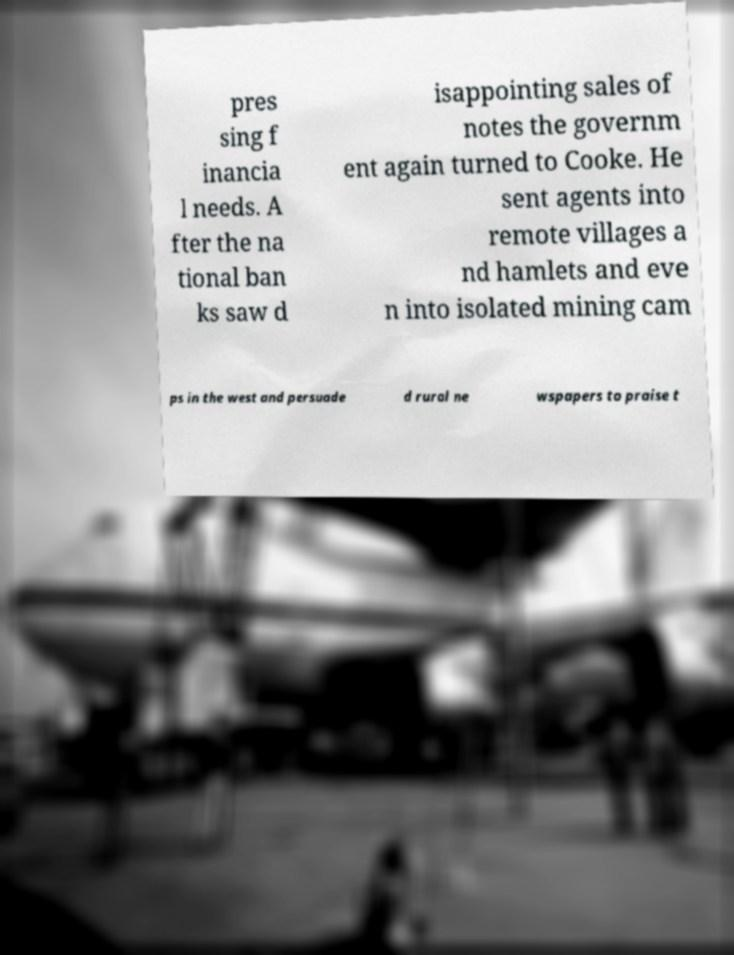Could you extract and type out the text from this image? pres sing f inancia l needs. A fter the na tional ban ks saw d isappointing sales of notes the governm ent again turned to Cooke. He sent agents into remote villages a nd hamlets and eve n into isolated mining cam ps in the west and persuade d rural ne wspapers to praise t 